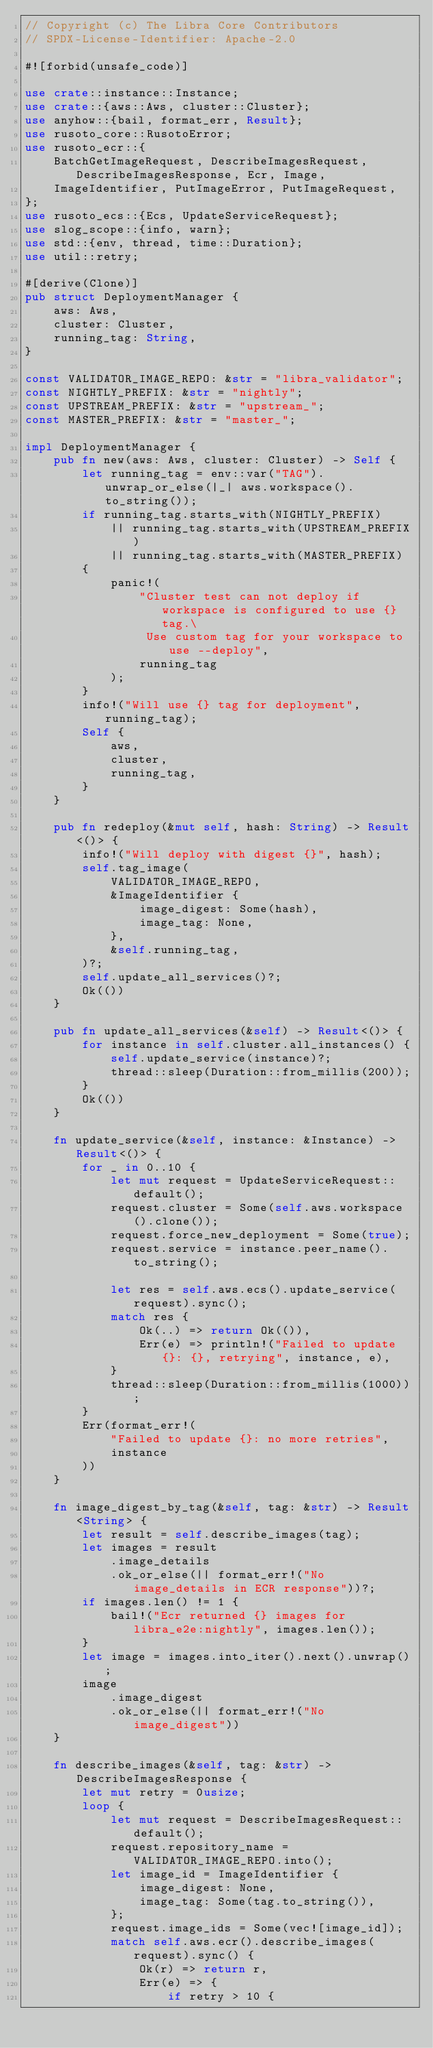<code> <loc_0><loc_0><loc_500><loc_500><_Rust_>// Copyright (c) The Libra Core Contributors
// SPDX-License-Identifier: Apache-2.0

#![forbid(unsafe_code)]

use crate::instance::Instance;
use crate::{aws::Aws, cluster::Cluster};
use anyhow::{bail, format_err, Result};
use rusoto_core::RusotoError;
use rusoto_ecr::{
    BatchGetImageRequest, DescribeImagesRequest, DescribeImagesResponse, Ecr, Image,
    ImageIdentifier, PutImageError, PutImageRequest,
};
use rusoto_ecs::{Ecs, UpdateServiceRequest};
use slog_scope::{info, warn};
use std::{env, thread, time::Duration};
use util::retry;

#[derive(Clone)]
pub struct DeploymentManager {
    aws: Aws,
    cluster: Cluster,
    running_tag: String,
}

const VALIDATOR_IMAGE_REPO: &str = "libra_validator";
const NIGHTLY_PREFIX: &str = "nightly";
const UPSTREAM_PREFIX: &str = "upstream_";
const MASTER_PREFIX: &str = "master_";

impl DeploymentManager {
    pub fn new(aws: Aws, cluster: Cluster) -> Self {
        let running_tag = env::var("TAG").unwrap_or_else(|_| aws.workspace().to_string());
        if running_tag.starts_with(NIGHTLY_PREFIX)
            || running_tag.starts_with(UPSTREAM_PREFIX)
            || running_tag.starts_with(MASTER_PREFIX)
        {
            panic!(
                "Cluster test can not deploy if workspace is configured to use {} tag.\
                 Use custom tag for your workspace to use --deploy",
                running_tag
            );
        }
        info!("Will use {} tag for deployment", running_tag);
        Self {
            aws,
            cluster,
            running_tag,
        }
    }

    pub fn redeploy(&mut self, hash: String) -> Result<()> {
        info!("Will deploy with digest {}", hash);
        self.tag_image(
            VALIDATOR_IMAGE_REPO,
            &ImageIdentifier {
                image_digest: Some(hash),
                image_tag: None,
            },
            &self.running_tag,
        )?;
        self.update_all_services()?;
        Ok(())
    }

    pub fn update_all_services(&self) -> Result<()> {
        for instance in self.cluster.all_instances() {
            self.update_service(instance)?;
            thread::sleep(Duration::from_millis(200));
        }
        Ok(())
    }

    fn update_service(&self, instance: &Instance) -> Result<()> {
        for _ in 0..10 {
            let mut request = UpdateServiceRequest::default();
            request.cluster = Some(self.aws.workspace().clone());
            request.force_new_deployment = Some(true);
            request.service = instance.peer_name().to_string();

            let res = self.aws.ecs().update_service(request).sync();
            match res {
                Ok(..) => return Ok(()),
                Err(e) => println!("Failed to update {}: {}, retrying", instance, e),
            }
            thread::sleep(Duration::from_millis(1000));
        }
        Err(format_err!(
            "Failed to update {}: no more retries",
            instance
        ))
    }

    fn image_digest_by_tag(&self, tag: &str) -> Result<String> {
        let result = self.describe_images(tag);
        let images = result
            .image_details
            .ok_or_else(|| format_err!("No image_details in ECR response"))?;
        if images.len() != 1 {
            bail!("Ecr returned {} images for libra_e2e:nightly", images.len());
        }
        let image = images.into_iter().next().unwrap();
        image
            .image_digest
            .ok_or_else(|| format_err!("No image_digest"))
    }

    fn describe_images(&self, tag: &str) -> DescribeImagesResponse {
        let mut retry = 0usize;
        loop {
            let mut request = DescribeImagesRequest::default();
            request.repository_name = VALIDATOR_IMAGE_REPO.into();
            let image_id = ImageIdentifier {
                image_digest: None,
                image_tag: Some(tag.to_string()),
            };
            request.image_ids = Some(vec![image_id]);
            match self.aws.ecr().describe_images(request).sync() {
                Ok(r) => return r,
                Err(e) => {
                    if retry > 10 {</code> 